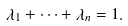<formula> <loc_0><loc_0><loc_500><loc_500>\lambda _ { 1 } + \cdots + \lambda _ { n } = 1 .</formula> 